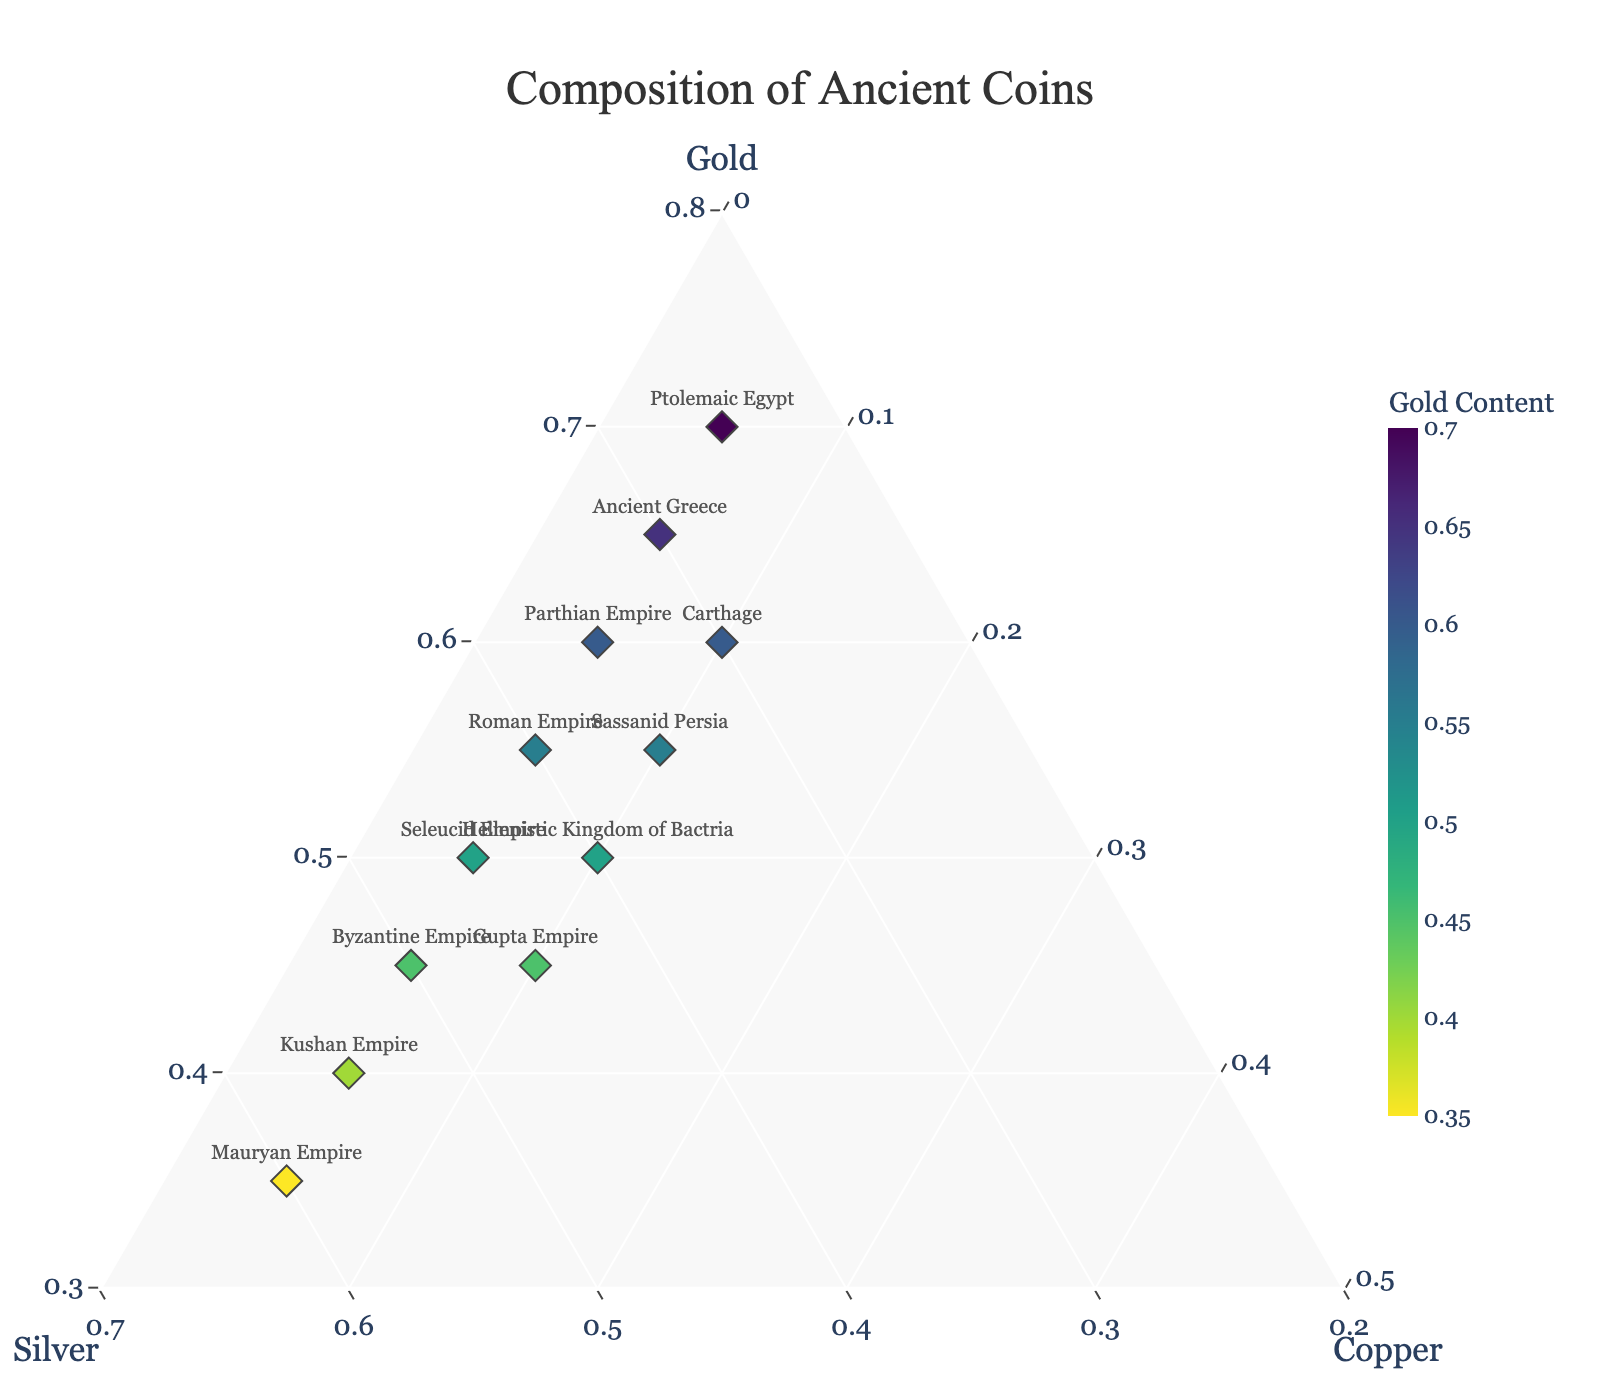What is the title of the figure? Look at the top of the figure where the title is located. Details about the composition of ancient coins are often summarized in the title.
Answer: Composition of Ancient Coins How many civilizations are represented in the plot? Count the data points representing different civilizations. Each marker with a civilization's name next to it represents one civilization.
Answer: 12 Which civilization has the highest gold content? Identify the marker positioned closest to the 'Gold' vertex (apex) of the ternary plot. This corresponds to the civilization with the highest gold proportion.
Answer: Ptolemaic Egypt What is the average proportion of silver across all civilizations? Sum the silver proportions for all civilizations and divide by the number of civilizations. Calculations: (0.30 + 0.40 + 0.25 + 0.50 + 0.35 + 0.45 + 0.55 + 0.35 + 0.60 + 0.45 + 0.30 + 0.40) / 12. Result is approximately 0.3958
Answer: 0.3958 Which civilization has an equal proportion of gold and silver? Look for the marker where the gold and silver proportions are equal by checking the coordinates given in the data. Each proportion should be the same along two axes.
Answer: Gupta Empire Which three civilizations have the lowest copper content, and what is their common copper proportion? Identify the civilizations with the lowest copper values as listed in the data. Since the copper value is the same for multiple civilizations, note the common value.
Answer: Ancient Greece, Roman Empire, Ptolemaic Egypt (copper content: 0.05) Between Byzantine Empire and Kushan Empire, which has a higher proportion of gold? Compare the gold proportions given in the data and determine which is higher.
Answer: Byzantine Empire (0.45 vs. 0.40) Which civilization has a gold content closest to the average gold content of all civilizations? First, calculate the average gold content: (0.65 + 0.55 + 0.70 + 0.45 + 0.60 + 0.50 + 0.40 + 0.55 + 0.35 + 0.45 + 0.60 + 0.50) / 12 ≈ 0.525. Then, compare each civilization’s gold content to this average and find the closest.
Answer: Roman Empire or Sassanid Persia (0.55) Which civilization has the highest silver content? Identify the marker positioned closest to the 'Silver' vertex of the ternary plot. This corresponds to the civilization with the highest silver proportion.
Answer: Mauryan Empire Which civilizations have the same proportion of gold and also the same proportion of copper? Check the civilizations in the data where both the gold and copper proportions are identical.
Answer: Roman Empire, Carthage 